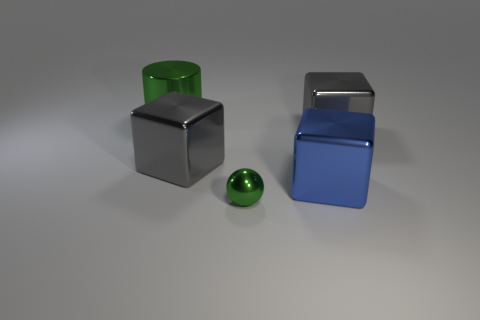Subtract all big blue metal blocks. How many blocks are left? 2 Subtract all blue cubes. How many cubes are left? 2 Add 2 big blue cubes. How many objects exist? 7 Subtract 1 balls. How many balls are left? 0 Subtract all red balls. How many gray blocks are left? 2 Subtract 0 cyan cylinders. How many objects are left? 5 Subtract all spheres. How many objects are left? 4 Subtract all gray cylinders. Subtract all purple balls. How many cylinders are left? 1 Subtract all green rubber cubes. Subtract all gray things. How many objects are left? 3 Add 5 green metallic things. How many green metallic things are left? 7 